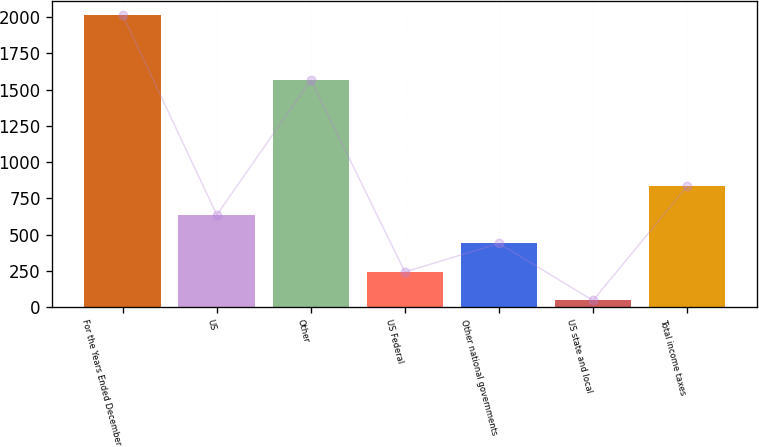Convert chart. <chart><loc_0><loc_0><loc_500><loc_500><bar_chart><fcel>For the Years Ended December<fcel>US<fcel>Other<fcel>US Federal<fcel>Other national governments<fcel>US state and local<fcel>Total income taxes<nl><fcel>2013<fcel>635.4<fcel>1566<fcel>241.8<fcel>438.6<fcel>45<fcel>832.2<nl></chart> 